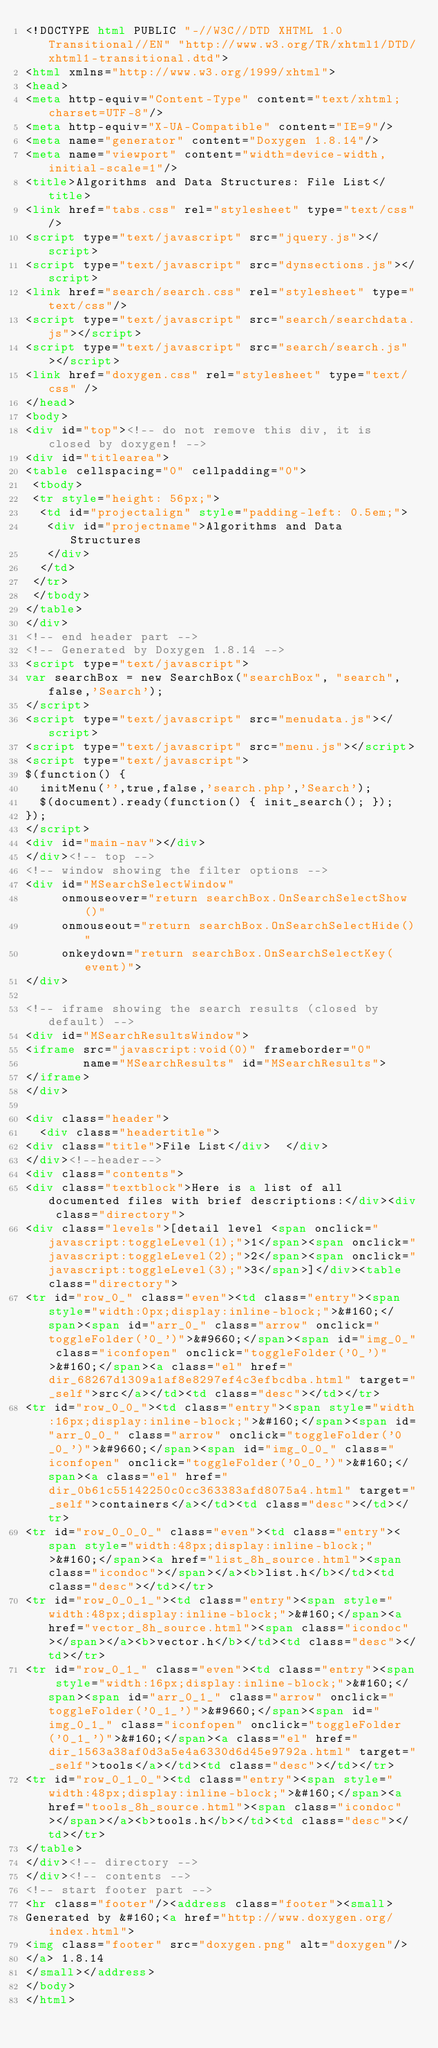Convert code to text. <code><loc_0><loc_0><loc_500><loc_500><_HTML_><!DOCTYPE html PUBLIC "-//W3C//DTD XHTML 1.0 Transitional//EN" "http://www.w3.org/TR/xhtml1/DTD/xhtml1-transitional.dtd">
<html xmlns="http://www.w3.org/1999/xhtml">
<head>
<meta http-equiv="Content-Type" content="text/xhtml;charset=UTF-8"/>
<meta http-equiv="X-UA-Compatible" content="IE=9"/>
<meta name="generator" content="Doxygen 1.8.14"/>
<meta name="viewport" content="width=device-width, initial-scale=1"/>
<title>Algorithms and Data Structures: File List</title>
<link href="tabs.css" rel="stylesheet" type="text/css"/>
<script type="text/javascript" src="jquery.js"></script>
<script type="text/javascript" src="dynsections.js"></script>
<link href="search/search.css" rel="stylesheet" type="text/css"/>
<script type="text/javascript" src="search/searchdata.js"></script>
<script type="text/javascript" src="search/search.js"></script>
<link href="doxygen.css" rel="stylesheet" type="text/css" />
</head>
<body>
<div id="top"><!-- do not remove this div, it is closed by doxygen! -->
<div id="titlearea">
<table cellspacing="0" cellpadding="0">
 <tbody>
 <tr style="height: 56px;">
  <td id="projectalign" style="padding-left: 0.5em;">
   <div id="projectname">Algorithms and Data Structures
   </div>
  </td>
 </tr>
 </tbody>
</table>
</div>
<!-- end header part -->
<!-- Generated by Doxygen 1.8.14 -->
<script type="text/javascript">
var searchBox = new SearchBox("searchBox", "search",false,'Search');
</script>
<script type="text/javascript" src="menudata.js"></script>
<script type="text/javascript" src="menu.js"></script>
<script type="text/javascript">
$(function() {
  initMenu('',true,false,'search.php','Search');
  $(document).ready(function() { init_search(); });
});
</script>
<div id="main-nav"></div>
</div><!-- top -->
<!-- window showing the filter options -->
<div id="MSearchSelectWindow"
     onmouseover="return searchBox.OnSearchSelectShow()"
     onmouseout="return searchBox.OnSearchSelectHide()"
     onkeydown="return searchBox.OnSearchSelectKey(event)">
</div>

<!-- iframe showing the search results (closed by default) -->
<div id="MSearchResultsWindow">
<iframe src="javascript:void(0)" frameborder="0" 
        name="MSearchResults" id="MSearchResults">
</iframe>
</div>

<div class="header">
  <div class="headertitle">
<div class="title">File List</div>  </div>
</div><!--header-->
<div class="contents">
<div class="textblock">Here is a list of all documented files with brief descriptions:</div><div class="directory">
<div class="levels">[detail level <span onclick="javascript:toggleLevel(1);">1</span><span onclick="javascript:toggleLevel(2);">2</span><span onclick="javascript:toggleLevel(3);">3</span>]</div><table class="directory">
<tr id="row_0_" class="even"><td class="entry"><span style="width:0px;display:inline-block;">&#160;</span><span id="arr_0_" class="arrow" onclick="toggleFolder('0_')">&#9660;</span><span id="img_0_" class="iconfopen" onclick="toggleFolder('0_')">&#160;</span><a class="el" href="dir_68267d1309a1af8e8297ef4c3efbcdba.html" target="_self">src</a></td><td class="desc"></td></tr>
<tr id="row_0_0_"><td class="entry"><span style="width:16px;display:inline-block;">&#160;</span><span id="arr_0_0_" class="arrow" onclick="toggleFolder('0_0_')">&#9660;</span><span id="img_0_0_" class="iconfopen" onclick="toggleFolder('0_0_')">&#160;</span><a class="el" href="dir_0b61c55142250c0cc363383afd8075a4.html" target="_self">containers</a></td><td class="desc"></td></tr>
<tr id="row_0_0_0_" class="even"><td class="entry"><span style="width:48px;display:inline-block;">&#160;</span><a href="list_8h_source.html"><span class="icondoc"></span></a><b>list.h</b></td><td class="desc"></td></tr>
<tr id="row_0_0_1_"><td class="entry"><span style="width:48px;display:inline-block;">&#160;</span><a href="vector_8h_source.html"><span class="icondoc"></span></a><b>vector.h</b></td><td class="desc"></td></tr>
<tr id="row_0_1_" class="even"><td class="entry"><span style="width:16px;display:inline-block;">&#160;</span><span id="arr_0_1_" class="arrow" onclick="toggleFolder('0_1_')">&#9660;</span><span id="img_0_1_" class="iconfopen" onclick="toggleFolder('0_1_')">&#160;</span><a class="el" href="dir_1563a38af0d3a5e4a6330d6d45e9792a.html" target="_self">tools</a></td><td class="desc"></td></tr>
<tr id="row_0_1_0_"><td class="entry"><span style="width:48px;display:inline-block;">&#160;</span><a href="tools_8h_source.html"><span class="icondoc"></span></a><b>tools.h</b></td><td class="desc"></td></tr>
</table>
</div><!-- directory -->
</div><!-- contents -->
<!-- start footer part -->
<hr class="footer"/><address class="footer"><small>
Generated by &#160;<a href="http://www.doxygen.org/index.html">
<img class="footer" src="doxygen.png" alt="doxygen"/>
</a> 1.8.14
</small></address>
</body>
</html>
</code> 